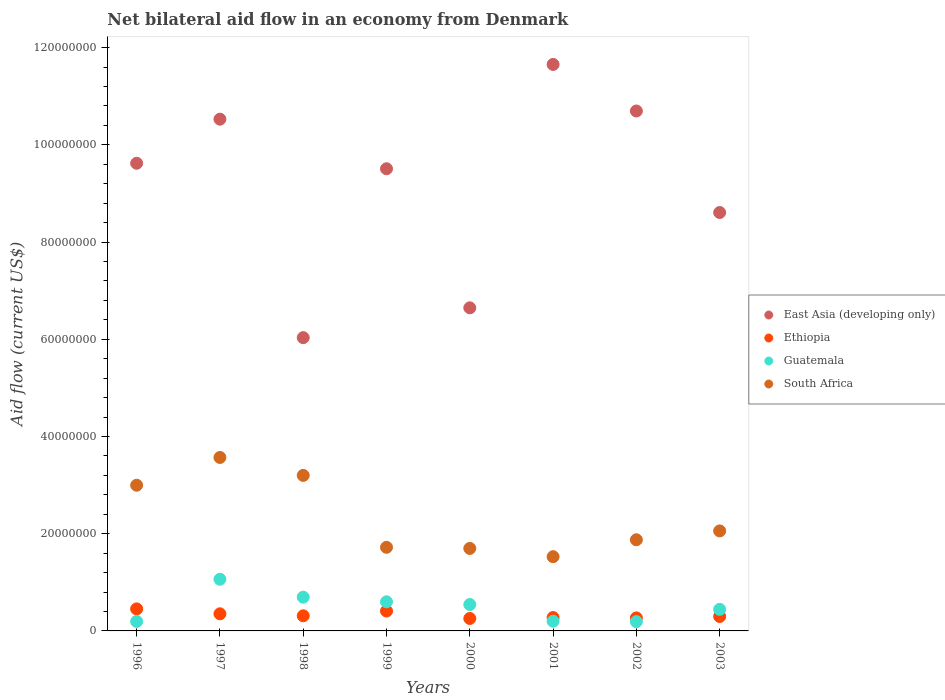Is the number of dotlines equal to the number of legend labels?
Ensure brevity in your answer.  Yes. What is the net bilateral aid flow in Ethiopia in 2000?
Keep it short and to the point. 2.56e+06. Across all years, what is the maximum net bilateral aid flow in Ethiopia?
Provide a short and direct response. 4.53e+06. Across all years, what is the minimum net bilateral aid flow in Ethiopia?
Keep it short and to the point. 2.56e+06. What is the total net bilateral aid flow in South Africa in the graph?
Offer a very short reply. 1.86e+08. What is the difference between the net bilateral aid flow in South Africa in 1999 and that in 2001?
Offer a terse response. 1.93e+06. What is the difference between the net bilateral aid flow in South Africa in 1998 and the net bilateral aid flow in East Asia (developing only) in 1999?
Your response must be concise. -6.31e+07. What is the average net bilateral aid flow in South Africa per year?
Your response must be concise. 2.33e+07. In the year 1998, what is the difference between the net bilateral aid flow in South Africa and net bilateral aid flow in East Asia (developing only)?
Your answer should be compact. -2.83e+07. In how many years, is the net bilateral aid flow in Guatemala greater than 92000000 US$?
Keep it short and to the point. 0. What is the ratio of the net bilateral aid flow in Ethiopia in 1997 to that in 1998?
Your response must be concise. 1.13. Is the net bilateral aid flow in Guatemala in 2000 less than that in 2001?
Provide a short and direct response. No. Is the difference between the net bilateral aid flow in South Africa in 1996 and 2001 greater than the difference between the net bilateral aid flow in East Asia (developing only) in 1996 and 2001?
Your answer should be compact. Yes. What is the difference between the highest and the second highest net bilateral aid flow in South Africa?
Provide a succinct answer. 3.69e+06. What is the difference between the highest and the lowest net bilateral aid flow in South Africa?
Offer a terse response. 2.04e+07. Does the net bilateral aid flow in Ethiopia monotonically increase over the years?
Provide a succinct answer. No. How many dotlines are there?
Your answer should be very brief. 4. How many years are there in the graph?
Your response must be concise. 8. What is the difference between two consecutive major ticks on the Y-axis?
Make the answer very short. 2.00e+07. Does the graph contain grids?
Offer a very short reply. No. How are the legend labels stacked?
Provide a succinct answer. Vertical. What is the title of the graph?
Keep it short and to the point. Net bilateral aid flow in an economy from Denmark. Does "Qatar" appear as one of the legend labels in the graph?
Your answer should be very brief. No. What is the label or title of the X-axis?
Provide a succinct answer. Years. What is the Aid flow (current US$) in East Asia (developing only) in 1996?
Offer a terse response. 9.62e+07. What is the Aid flow (current US$) in Ethiopia in 1996?
Provide a succinct answer. 4.53e+06. What is the Aid flow (current US$) of Guatemala in 1996?
Offer a terse response. 1.95e+06. What is the Aid flow (current US$) of South Africa in 1996?
Offer a very short reply. 3.00e+07. What is the Aid flow (current US$) of East Asia (developing only) in 1997?
Ensure brevity in your answer.  1.05e+08. What is the Aid flow (current US$) in Ethiopia in 1997?
Offer a terse response. 3.52e+06. What is the Aid flow (current US$) in Guatemala in 1997?
Offer a terse response. 1.06e+07. What is the Aid flow (current US$) in South Africa in 1997?
Provide a short and direct response. 3.57e+07. What is the Aid flow (current US$) in East Asia (developing only) in 1998?
Offer a terse response. 6.03e+07. What is the Aid flow (current US$) in Ethiopia in 1998?
Your answer should be very brief. 3.11e+06. What is the Aid flow (current US$) in Guatemala in 1998?
Provide a succinct answer. 6.94e+06. What is the Aid flow (current US$) of South Africa in 1998?
Make the answer very short. 3.20e+07. What is the Aid flow (current US$) in East Asia (developing only) in 1999?
Offer a terse response. 9.51e+07. What is the Aid flow (current US$) of Ethiopia in 1999?
Make the answer very short. 4.09e+06. What is the Aid flow (current US$) in Guatemala in 1999?
Keep it short and to the point. 5.99e+06. What is the Aid flow (current US$) in South Africa in 1999?
Offer a very short reply. 1.72e+07. What is the Aid flow (current US$) in East Asia (developing only) in 2000?
Make the answer very short. 6.65e+07. What is the Aid flow (current US$) of Ethiopia in 2000?
Give a very brief answer. 2.56e+06. What is the Aid flow (current US$) in Guatemala in 2000?
Your answer should be compact. 5.43e+06. What is the Aid flow (current US$) of South Africa in 2000?
Your answer should be compact. 1.70e+07. What is the Aid flow (current US$) in East Asia (developing only) in 2001?
Your answer should be compact. 1.17e+08. What is the Aid flow (current US$) in Ethiopia in 2001?
Offer a very short reply. 2.75e+06. What is the Aid flow (current US$) in Guatemala in 2001?
Keep it short and to the point. 2.00e+06. What is the Aid flow (current US$) in South Africa in 2001?
Keep it short and to the point. 1.53e+07. What is the Aid flow (current US$) of East Asia (developing only) in 2002?
Provide a succinct answer. 1.07e+08. What is the Aid flow (current US$) in Ethiopia in 2002?
Ensure brevity in your answer.  2.68e+06. What is the Aid flow (current US$) in Guatemala in 2002?
Give a very brief answer. 1.91e+06. What is the Aid flow (current US$) of South Africa in 2002?
Provide a succinct answer. 1.88e+07. What is the Aid flow (current US$) in East Asia (developing only) in 2003?
Give a very brief answer. 8.61e+07. What is the Aid flow (current US$) of Ethiopia in 2003?
Provide a succinct answer. 2.97e+06. What is the Aid flow (current US$) of Guatemala in 2003?
Keep it short and to the point. 4.44e+06. What is the Aid flow (current US$) of South Africa in 2003?
Offer a very short reply. 2.06e+07. Across all years, what is the maximum Aid flow (current US$) of East Asia (developing only)?
Keep it short and to the point. 1.17e+08. Across all years, what is the maximum Aid flow (current US$) in Ethiopia?
Your answer should be compact. 4.53e+06. Across all years, what is the maximum Aid flow (current US$) in Guatemala?
Keep it short and to the point. 1.06e+07. Across all years, what is the maximum Aid flow (current US$) of South Africa?
Your response must be concise. 3.57e+07. Across all years, what is the minimum Aid flow (current US$) of East Asia (developing only)?
Your response must be concise. 6.03e+07. Across all years, what is the minimum Aid flow (current US$) of Ethiopia?
Offer a terse response. 2.56e+06. Across all years, what is the minimum Aid flow (current US$) of Guatemala?
Provide a short and direct response. 1.91e+06. Across all years, what is the minimum Aid flow (current US$) in South Africa?
Make the answer very short. 1.53e+07. What is the total Aid flow (current US$) of East Asia (developing only) in the graph?
Provide a succinct answer. 7.33e+08. What is the total Aid flow (current US$) of Ethiopia in the graph?
Offer a very short reply. 2.62e+07. What is the total Aid flow (current US$) in Guatemala in the graph?
Provide a succinct answer. 3.93e+07. What is the total Aid flow (current US$) in South Africa in the graph?
Give a very brief answer. 1.86e+08. What is the difference between the Aid flow (current US$) of East Asia (developing only) in 1996 and that in 1997?
Your response must be concise. -9.07e+06. What is the difference between the Aid flow (current US$) in Ethiopia in 1996 and that in 1997?
Ensure brevity in your answer.  1.01e+06. What is the difference between the Aid flow (current US$) of Guatemala in 1996 and that in 1997?
Your answer should be compact. -8.68e+06. What is the difference between the Aid flow (current US$) of South Africa in 1996 and that in 1997?
Provide a succinct answer. -5.71e+06. What is the difference between the Aid flow (current US$) in East Asia (developing only) in 1996 and that in 1998?
Offer a terse response. 3.59e+07. What is the difference between the Aid flow (current US$) in Ethiopia in 1996 and that in 1998?
Your answer should be compact. 1.42e+06. What is the difference between the Aid flow (current US$) of Guatemala in 1996 and that in 1998?
Offer a terse response. -4.99e+06. What is the difference between the Aid flow (current US$) of South Africa in 1996 and that in 1998?
Offer a very short reply. -2.02e+06. What is the difference between the Aid flow (current US$) in East Asia (developing only) in 1996 and that in 1999?
Offer a very short reply. 1.13e+06. What is the difference between the Aid flow (current US$) in Ethiopia in 1996 and that in 1999?
Provide a short and direct response. 4.40e+05. What is the difference between the Aid flow (current US$) of Guatemala in 1996 and that in 1999?
Offer a very short reply. -4.04e+06. What is the difference between the Aid flow (current US$) of South Africa in 1996 and that in 1999?
Keep it short and to the point. 1.28e+07. What is the difference between the Aid flow (current US$) in East Asia (developing only) in 1996 and that in 2000?
Offer a terse response. 2.97e+07. What is the difference between the Aid flow (current US$) in Ethiopia in 1996 and that in 2000?
Provide a short and direct response. 1.97e+06. What is the difference between the Aid flow (current US$) in Guatemala in 1996 and that in 2000?
Keep it short and to the point. -3.48e+06. What is the difference between the Aid flow (current US$) of South Africa in 1996 and that in 2000?
Make the answer very short. 1.30e+07. What is the difference between the Aid flow (current US$) of East Asia (developing only) in 1996 and that in 2001?
Your answer should be very brief. -2.03e+07. What is the difference between the Aid flow (current US$) in Ethiopia in 1996 and that in 2001?
Keep it short and to the point. 1.78e+06. What is the difference between the Aid flow (current US$) in Guatemala in 1996 and that in 2001?
Offer a very short reply. -5.00e+04. What is the difference between the Aid flow (current US$) in South Africa in 1996 and that in 2001?
Ensure brevity in your answer.  1.47e+07. What is the difference between the Aid flow (current US$) of East Asia (developing only) in 1996 and that in 2002?
Your answer should be very brief. -1.08e+07. What is the difference between the Aid flow (current US$) of Ethiopia in 1996 and that in 2002?
Your answer should be very brief. 1.85e+06. What is the difference between the Aid flow (current US$) in Guatemala in 1996 and that in 2002?
Your answer should be very brief. 4.00e+04. What is the difference between the Aid flow (current US$) in South Africa in 1996 and that in 2002?
Your answer should be compact. 1.12e+07. What is the difference between the Aid flow (current US$) of East Asia (developing only) in 1996 and that in 2003?
Keep it short and to the point. 1.01e+07. What is the difference between the Aid flow (current US$) in Ethiopia in 1996 and that in 2003?
Your answer should be very brief. 1.56e+06. What is the difference between the Aid flow (current US$) in Guatemala in 1996 and that in 2003?
Your answer should be compact. -2.49e+06. What is the difference between the Aid flow (current US$) in South Africa in 1996 and that in 2003?
Your answer should be compact. 9.40e+06. What is the difference between the Aid flow (current US$) in East Asia (developing only) in 1997 and that in 1998?
Make the answer very short. 4.49e+07. What is the difference between the Aid flow (current US$) in Guatemala in 1997 and that in 1998?
Make the answer very short. 3.69e+06. What is the difference between the Aid flow (current US$) in South Africa in 1997 and that in 1998?
Provide a short and direct response. 3.69e+06. What is the difference between the Aid flow (current US$) in East Asia (developing only) in 1997 and that in 1999?
Offer a terse response. 1.02e+07. What is the difference between the Aid flow (current US$) of Ethiopia in 1997 and that in 1999?
Give a very brief answer. -5.70e+05. What is the difference between the Aid flow (current US$) of Guatemala in 1997 and that in 1999?
Give a very brief answer. 4.64e+06. What is the difference between the Aid flow (current US$) of South Africa in 1997 and that in 1999?
Make the answer very short. 1.85e+07. What is the difference between the Aid flow (current US$) in East Asia (developing only) in 1997 and that in 2000?
Offer a very short reply. 3.88e+07. What is the difference between the Aid flow (current US$) of Ethiopia in 1997 and that in 2000?
Ensure brevity in your answer.  9.60e+05. What is the difference between the Aid flow (current US$) in Guatemala in 1997 and that in 2000?
Your response must be concise. 5.20e+06. What is the difference between the Aid flow (current US$) in South Africa in 1997 and that in 2000?
Offer a terse response. 1.87e+07. What is the difference between the Aid flow (current US$) of East Asia (developing only) in 1997 and that in 2001?
Provide a succinct answer. -1.13e+07. What is the difference between the Aid flow (current US$) in Ethiopia in 1997 and that in 2001?
Your response must be concise. 7.70e+05. What is the difference between the Aid flow (current US$) in Guatemala in 1997 and that in 2001?
Your response must be concise. 8.63e+06. What is the difference between the Aid flow (current US$) in South Africa in 1997 and that in 2001?
Make the answer very short. 2.04e+07. What is the difference between the Aid flow (current US$) in East Asia (developing only) in 1997 and that in 2002?
Offer a very short reply. -1.68e+06. What is the difference between the Aid flow (current US$) of Ethiopia in 1997 and that in 2002?
Ensure brevity in your answer.  8.40e+05. What is the difference between the Aid flow (current US$) in Guatemala in 1997 and that in 2002?
Your answer should be very brief. 8.72e+06. What is the difference between the Aid flow (current US$) in South Africa in 1997 and that in 2002?
Provide a short and direct response. 1.69e+07. What is the difference between the Aid flow (current US$) of East Asia (developing only) in 1997 and that in 2003?
Offer a very short reply. 1.92e+07. What is the difference between the Aid flow (current US$) in Ethiopia in 1997 and that in 2003?
Provide a succinct answer. 5.50e+05. What is the difference between the Aid flow (current US$) of Guatemala in 1997 and that in 2003?
Your response must be concise. 6.19e+06. What is the difference between the Aid flow (current US$) in South Africa in 1997 and that in 2003?
Ensure brevity in your answer.  1.51e+07. What is the difference between the Aid flow (current US$) in East Asia (developing only) in 1998 and that in 1999?
Keep it short and to the point. -3.47e+07. What is the difference between the Aid flow (current US$) in Ethiopia in 1998 and that in 1999?
Ensure brevity in your answer.  -9.80e+05. What is the difference between the Aid flow (current US$) of Guatemala in 1998 and that in 1999?
Provide a short and direct response. 9.50e+05. What is the difference between the Aid flow (current US$) of South Africa in 1998 and that in 1999?
Make the answer very short. 1.48e+07. What is the difference between the Aid flow (current US$) of East Asia (developing only) in 1998 and that in 2000?
Provide a succinct answer. -6.13e+06. What is the difference between the Aid flow (current US$) of Guatemala in 1998 and that in 2000?
Your answer should be very brief. 1.51e+06. What is the difference between the Aid flow (current US$) in South Africa in 1998 and that in 2000?
Provide a succinct answer. 1.50e+07. What is the difference between the Aid flow (current US$) in East Asia (developing only) in 1998 and that in 2001?
Ensure brevity in your answer.  -5.62e+07. What is the difference between the Aid flow (current US$) in Guatemala in 1998 and that in 2001?
Ensure brevity in your answer.  4.94e+06. What is the difference between the Aid flow (current US$) in South Africa in 1998 and that in 2001?
Offer a very short reply. 1.67e+07. What is the difference between the Aid flow (current US$) in East Asia (developing only) in 1998 and that in 2002?
Your answer should be compact. -4.66e+07. What is the difference between the Aid flow (current US$) in Guatemala in 1998 and that in 2002?
Your answer should be compact. 5.03e+06. What is the difference between the Aid flow (current US$) in South Africa in 1998 and that in 2002?
Make the answer very short. 1.32e+07. What is the difference between the Aid flow (current US$) in East Asia (developing only) in 1998 and that in 2003?
Ensure brevity in your answer.  -2.57e+07. What is the difference between the Aid flow (current US$) of Ethiopia in 1998 and that in 2003?
Provide a short and direct response. 1.40e+05. What is the difference between the Aid flow (current US$) of Guatemala in 1998 and that in 2003?
Make the answer very short. 2.50e+06. What is the difference between the Aid flow (current US$) of South Africa in 1998 and that in 2003?
Offer a terse response. 1.14e+07. What is the difference between the Aid flow (current US$) in East Asia (developing only) in 1999 and that in 2000?
Ensure brevity in your answer.  2.86e+07. What is the difference between the Aid flow (current US$) in Ethiopia in 1999 and that in 2000?
Offer a terse response. 1.53e+06. What is the difference between the Aid flow (current US$) in Guatemala in 1999 and that in 2000?
Provide a succinct answer. 5.60e+05. What is the difference between the Aid flow (current US$) in South Africa in 1999 and that in 2000?
Make the answer very short. 2.30e+05. What is the difference between the Aid flow (current US$) of East Asia (developing only) in 1999 and that in 2001?
Provide a short and direct response. -2.15e+07. What is the difference between the Aid flow (current US$) of Ethiopia in 1999 and that in 2001?
Make the answer very short. 1.34e+06. What is the difference between the Aid flow (current US$) of Guatemala in 1999 and that in 2001?
Keep it short and to the point. 3.99e+06. What is the difference between the Aid flow (current US$) in South Africa in 1999 and that in 2001?
Offer a very short reply. 1.93e+06. What is the difference between the Aid flow (current US$) in East Asia (developing only) in 1999 and that in 2002?
Provide a succinct answer. -1.19e+07. What is the difference between the Aid flow (current US$) in Ethiopia in 1999 and that in 2002?
Give a very brief answer. 1.41e+06. What is the difference between the Aid flow (current US$) in Guatemala in 1999 and that in 2002?
Keep it short and to the point. 4.08e+06. What is the difference between the Aid flow (current US$) in South Africa in 1999 and that in 2002?
Ensure brevity in your answer.  -1.55e+06. What is the difference between the Aid flow (current US$) in East Asia (developing only) in 1999 and that in 2003?
Provide a short and direct response. 9.00e+06. What is the difference between the Aid flow (current US$) in Ethiopia in 1999 and that in 2003?
Offer a terse response. 1.12e+06. What is the difference between the Aid flow (current US$) in Guatemala in 1999 and that in 2003?
Keep it short and to the point. 1.55e+06. What is the difference between the Aid flow (current US$) of South Africa in 1999 and that in 2003?
Give a very brief answer. -3.37e+06. What is the difference between the Aid flow (current US$) of East Asia (developing only) in 2000 and that in 2001?
Offer a terse response. -5.01e+07. What is the difference between the Aid flow (current US$) in Ethiopia in 2000 and that in 2001?
Offer a very short reply. -1.90e+05. What is the difference between the Aid flow (current US$) of Guatemala in 2000 and that in 2001?
Your response must be concise. 3.43e+06. What is the difference between the Aid flow (current US$) in South Africa in 2000 and that in 2001?
Give a very brief answer. 1.70e+06. What is the difference between the Aid flow (current US$) in East Asia (developing only) in 2000 and that in 2002?
Offer a very short reply. -4.05e+07. What is the difference between the Aid flow (current US$) of Ethiopia in 2000 and that in 2002?
Your answer should be compact. -1.20e+05. What is the difference between the Aid flow (current US$) of Guatemala in 2000 and that in 2002?
Your answer should be very brief. 3.52e+06. What is the difference between the Aid flow (current US$) in South Africa in 2000 and that in 2002?
Your answer should be compact. -1.78e+06. What is the difference between the Aid flow (current US$) of East Asia (developing only) in 2000 and that in 2003?
Your response must be concise. -1.96e+07. What is the difference between the Aid flow (current US$) of Ethiopia in 2000 and that in 2003?
Make the answer very short. -4.10e+05. What is the difference between the Aid flow (current US$) of Guatemala in 2000 and that in 2003?
Ensure brevity in your answer.  9.90e+05. What is the difference between the Aid flow (current US$) in South Africa in 2000 and that in 2003?
Offer a terse response. -3.60e+06. What is the difference between the Aid flow (current US$) of East Asia (developing only) in 2001 and that in 2002?
Make the answer very short. 9.58e+06. What is the difference between the Aid flow (current US$) of South Africa in 2001 and that in 2002?
Your response must be concise. -3.48e+06. What is the difference between the Aid flow (current US$) of East Asia (developing only) in 2001 and that in 2003?
Keep it short and to the point. 3.05e+07. What is the difference between the Aid flow (current US$) in Guatemala in 2001 and that in 2003?
Your response must be concise. -2.44e+06. What is the difference between the Aid flow (current US$) in South Africa in 2001 and that in 2003?
Offer a very short reply. -5.30e+06. What is the difference between the Aid flow (current US$) in East Asia (developing only) in 2002 and that in 2003?
Provide a succinct answer. 2.09e+07. What is the difference between the Aid flow (current US$) of Ethiopia in 2002 and that in 2003?
Your response must be concise. -2.90e+05. What is the difference between the Aid flow (current US$) of Guatemala in 2002 and that in 2003?
Your response must be concise. -2.53e+06. What is the difference between the Aid flow (current US$) of South Africa in 2002 and that in 2003?
Make the answer very short. -1.82e+06. What is the difference between the Aid flow (current US$) of East Asia (developing only) in 1996 and the Aid flow (current US$) of Ethiopia in 1997?
Provide a succinct answer. 9.27e+07. What is the difference between the Aid flow (current US$) of East Asia (developing only) in 1996 and the Aid flow (current US$) of Guatemala in 1997?
Your answer should be very brief. 8.56e+07. What is the difference between the Aid flow (current US$) in East Asia (developing only) in 1996 and the Aid flow (current US$) in South Africa in 1997?
Provide a short and direct response. 6.05e+07. What is the difference between the Aid flow (current US$) in Ethiopia in 1996 and the Aid flow (current US$) in Guatemala in 1997?
Provide a succinct answer. -6.10e+06. What is the difference between the Aid flow (current US$) in Ethiopia in 1996 and the Aid flow (current US$) in South Africa in 1997?
Provide a succinct answer. -3.12e+07. What is the difference between the Aid flow (current US$) of Guatemala in 1996 and the Aid flow (current US$) of South Africa in 1997?
Provide a short and direct response. -3.37e+07. What is the difference between the Aid flow (current US$) of East Asia (developing only) in 1996 and the Aid flow (current US$) of Ethiopia in 1998?
Make the answer very short. 9.31e+07. What is the difference between the Aid flow (current US$) of East Asia (developing only) in 1996 and the Aid flow (current US$) of Guatemala in 1998?
Provide a short and direct response. 8.93e+07. What is the difference between the Aid flow (current US$) of East Asia (developing only) in 1996 and the Aid flow (current US$) of South Africa in 1998?
Give a very brief answer. 6.42e+07. What is the difference between the Aid flow (current US$) of Ethiopia in 1996 and the Aid flow (current US$) of Guatemala in 1998?
Keep it short and to the point. -2.41e+06. What is the difference between the Aid flow (current US$) of Ethiopia in 1996 and the Aid flow (current US$) of South Africa in 1998?
Provide a succinct answer. -2.75e+07. What is the difference between the Aid flow (current US$) in Guatemala in 1996 and the Aid flow (current US$) in South Africa in 1998?
Give a very brief answer. -3.00e+07. What is the difference between the Aid flow (current US$) in East Asia (developing only) in 1996 and the Aid flow (current US$) in Ethiopia in 1999?
Your answer should be very brief. 9.21e+07. What is the difference between the Aid flow (current US$) in East Asia (developing only) in 1996 and the Aid flow (current US$) in Guatemala in 1999?
Offer a terse response. 9.02e+07. What is the difference between the Aid flow (current US$) of East Asia (developing only) in 1996 and the Aid flow (current US$) of South Africa in 1999?
Make the answer very short. 7.90e+07. What is the difference between the Aid flow (current US$) in Ethiopia in 1996 and the Aid flow (current US$) in Guatemala in 1999?
Your response must be concise. -1.46e+06. What is the difference between the Aid flow (current US$) in Ethiopia in 1996 and the Aid flow (current US$) in South Africa in 1999?
Provide a succinct answer. -1.27e+07. What is the difference between the Aid flow (current US$) of Guatemala in 1996 and the Aid flow (current US$) of South Africa in 1999?
Your answer should be compact. -1.52e+07. What is the difference between the Aid flow (current US$) of East Asia (developing only) in 1996 and the Aid flow (current US$) of Ethiopia in 2000?
Give a very brief answer. 9.36e+07. What is the difference between the Aid flow (current US$) in East Asia (developing only) in 1996 and the Aid flow (current US$) in Guatemala in 2000?
Ensure brevity in your answer.  9.08e+07. What is the difference between the Aid flow (current US$) of East Asia (developing only) in 1996 and the Aid flow (current US$) of South Africa in 2000?
Provide a succinct answer. 7.92e+07. What is the difference between the Aid flow (current US$) in Ethiopia in 1996 and the Aid flow (current US$) in Guatemala in 2000?
Your answer should be compact. -9.00e+05. What is the difference between the Aid flow (current US$) of Ethiopia in 1996 and the Aid flow (current US$) of South Africa in 2000?
Offer a very short reply. -1.24e+07. What is the difference between the Aid flow (current US$) in Guatemala in 1996 and the Aid flow (current US$) in South Africa in 2000?
Your answer should be compact. -1.50e+07. What is the difference between the Aid flow (current US$) of East Asia (developing only) in 1996 and the Aid flow (current US$) of Ethiopia in 2001?
Give a very brief answer. 9.34e+07. What is the difference between the Aid flow (current US$) in East Asia (developing only) in 1996 and the Aid flow (current US$) in Guatemala in 2001?
Give a very brief answer. 9.42e+07. What is the difference between the Aid flow (current US$) in East Asia (developing only) in 1996 and the Aid flow (current US$) in South Africa in 2001?
Offer a very short reply. 8.09e+07. What is the difference between the Aid flow (current US$) of Ethiopia in 1996 and the Aid flow (current US$) of Guatemala in 2001?
Offer a very short reply. 2.53e+06. What is the difference between the Aid flow (current US$) of Ethiopia in 1996 and the Aid flow (current US$) of South Africa in 2001?
Your answer should be very brief. -1.07e+07. What is the difference between the Aid flow (current US$) of Guatemala in 1996 and the Aid flow (current US$) of South Africa in 2001?
Provide a succinct answer. -1.33e+07. What is the difference between the Aid flow (current US$) in East Asia (developing only) in 1996 and the Aid flow (current US$) in Ethiopia in 2002?
Your answer should be very brief. 9.35e+07. What is the difference between the Aid flow (current US$) in East Asia (developing only) in 1996 and the Aid flow (current US$) in Guatemala in 2002?
Your response must be concise. 9.43e+07. What is the difference between the Aid flow (current US$) of East Asia (developing only) in 1996 and the Aid flow (current US$) of South Africa in 2002?
Provide a short and direct response. 7.74e+07. What is the difference between the Aid flow (current US$) in Ethiopia in 1996 and the Aid flow (current US$) in Guatemala in 2002?
Offer a terse response. 2.62e+06. What is the difference between the Aid flow (current US$) in Ethiopia in 1996 and the Aid flow (current US$) in South Africa in 2002?
Provide a short and direct response. -1.42e+07. What is the difference between the Aid flow (current US$) of Guatemala in 1996 and the Aid flow (current US$) of South Africa in 2002?
Your response must be concise. -1.68e+07. What is the difference between the Aid flow (current US$) of East Asia (developing only) in 1996 and the Aid flow (current US$) of Ethiopia in 2003?
Make the answer very short. 9.32e+07. What is the difference between the Aid flow (current US$) of East Asia (developing only) in 1996 and the Aid flow (current US$) of Guatemala in 2003?
Make the answer very short. 9.18e+07. What is the difference between the Aid flow (current US$) of East Asia (developing only) in 1996 and the Aid flow (current US$) of South Africa in 2003?
Provide a short and direct response. 7.56e+07. What is the difference between the Aid flow (current US$) of Ethiopia in 1996 and the Aid flow (current US$) of Guatemala in 2003?
Offer a very short reply. 9.00e+04. What is the difference between the Aid flow (current US$) of Ethiopia in 1996 and the Aid flow (current US$) of South Africa in 2003?
Ensure brevity in your answer.  -1.60e+07. What is the difference between the Aid flow (current US$) in Guatemala in 1996 and the Aid flow (current US$) in South Africa in 2003?
Your answer should be very brief. -1.86e+07. What is the difference between the Aid flow (current US$) in East Asia (developing only) in 1997 and the Aid flow (current US$) in Ethiopia in 1998?
Provide a succinct answer. 1.02e+08. What is the difference between the Aid flow (current US$) of East Asia (developing only) in 1997 and the Aid flow (current US$) of Guatemala in 1998?
Give a very brief answer. 9.83e+07. What is the difference between the Aid flow (current US$) in East Asia (developing only) in 1997 and the Aid flow (current US$) in South Africa in 1998?
Provide a short and direct response. 7.33e+07. What is the difference between the Aid flow (current US$) in Ethiopia in 1997 and the Aid flow (current US$) in Guatemala in 1998?
Your response must be concise. -3.42e+06. What is the difference between the Aid flow (current US$) in Ethiopia in 1997 and the Aid flow (current US$) in South Africa in 1998?
Provide a succinct answer. -2.85e+07. What is the difference between the Aid flow (current US$) of Guatemala in 1997 and the Aid flow (current US$) of South Africa in 1998?
Your response must be concise. -2.14e+07. What is the difference between the Aid flow (current US$) in East Asia (developing only) in 1997 and the Aid flow (current US$) in Ethiopia in 1999?
Provide a short and direct response. 1.01e+08. What is the difference between the Aid flow (current US$) of East Asia (developing only) in 1997 and the Aid flow (current US$) of Guatemala in 1999?
Provide a succinct answer. 9.93e+07. What is the difference between the Aid flow (current US$) of East Asia (developing only) in 1997 and the Aid flow (current US$) of South Africa in 1999?
Provide a short and direct response. 8.81e+07. What is the difference between the Aid flow (current US$) in Ethiopia in 1997 and the Aid flow (current US$) in Guatemala in 1999?
Your response must be concise. -2.47e+06. What is the difference between the Aid flow (current US$) in Ethiopia in 1997 and the Aid flow (current US$) in South Africa in 1999?
Your response must be concise. -1.37e+07. What is the difference between the Aid flow (current US$) in Guatemala in 1997 and the Aid flow (current US$) in South Africa in 1999?
Ensure brevity in your answer.  -6.57e+06. What is the difference between the Aid flow (current US$) in East Asia (developing only) in 1997 and the Aid flow (current US$) in Ethiopia in 2000?
Your answer should be very brief. 1.03e+08. What is the difference between the Aid flow (current US$) in East Asia (developing only) in 1997 and the Aid flow (current US$) in Guatemala in 2000?
Offer a very short reply. 9.98e+07. What is the difference between the Aid flow (current US$) of East Asia (developing only) in 1997 and the Aid flow (current US$) of South Africa in 2000?
Keep it short and to the point. 8.83e+07. What is the difference between the Aid flow (current US$) of Ethiopia in 1997 and the Aid flow (current US$) of Guatemala in 2000?
Ensure brevity in your answer.  -1.91e+06. What is the difference between the Aid flow (current US$) of Ethiopia in 1997 and the Aid flow (current US$) of South Africa in 2000?
Ensure brevity in your answer.  -1.34e+07. What is the difference between the Aid flow (current US$) of Guatemala in 1997 and the Aid flow (current US$) of South Africa in 2000?
Offer a very short reply. -6.34e+06. What is the difference between the Aid flow (current US$) in East Asia (developing only) in 1997 and the Aid flow (current US$) in Ethiopia in 2001?
Your response must be concise. 1.03e+08. What is the difference between the Aid flow (current US$) in East Asia (developing only) in 1997 and the Aid flow (current US$) in Guatemala in 2001?
Make the answer very short. 1.03e+08. What is the difference between the Aid flow (current US$) of East Asia (developing only) in 1997 and the Aid flow (current US$) of South Africa in 2001?
Provide a short and direct response. 9.00e+07. What is the difference between the Aid flow (current US$) in Ethiopia in 1997 and the Aid flow (current US$) in Guatemala in 2001?
Your answer should be very brief. 1.52e+06. What is the difference between the Aid flow (current US$) of Ethiopia in 1997 and the Aid flow (current US$) of South Africa in 2001?
Give a very brief answer. -1.18e+07. What is the difference between the Aid flow (current US$) of Guatemala in 1997 and the Aid flow (current US$) of South Africa in 2001?
Provide a succinct answer. -4.64e+06. What is the difference between the Aid flow (current US$) in East Asia (developing only) in 1997 and the Aid flow (current US$) in Ethiopia in 2002?
Give a very brief answer. 1.03e+08. What is the difference between the Aid flow (current US$) of East Asia (developing only) in 1997 and the Aid flow (current US$) of Guatemala in 2002?
Your answer should be very brief. 1.03e+08. What is the difference between the Aid flow (current US$) in East Asia (developing only) in 1997 and the Aid flow (current US$) in South Africa in 2002?
Provide a succinct answer. 8.65e+07. What is the difference between the Aid flow (current US$) of Ethiopia in 1997 and the Aid flow (current US$) of Guatemala in 2002?
Provide a short and direct response. 1.61e+06. What is the difference between the Aid flow (current US$) in Ethiopia in 1997 and the Aid flow (current US$) in South Africa in 2002?
Your answer should be compact. -1.52e+07. What is the difference between the Aid flow (current US$) in Guatemala in 1997 and the Aid flow (current US$) in South Africa in 2002?
Offer a terse response. -8.12e+06. What is the difference between the Aid flow (current US$) in East Asia (developing only) in 1997 and the Aid flow (current US$) in Ethiopia in 2003?
Keep it short and to the point. 1.02e+08. What is the difference between the Aid flow (current US$) of East Asia (developing only) in 1997 and the Aid flow (current US$) of Guatemala in 2003?
Ensure brevity in your answer.  1.01e+08. What is the difference between the Aid flow (current US$) in East Asia (developing only) in 1997 and the Aid flow (current US$) in South Africa in 2003?
Offer a terse response. 8.47e+07. What is the difference between the Aid flow (current US$) of Ethiopia in 1997 and the Aid flow (current US$) of Guatemala in 2003?
Give a very brief answer. -9.20e+05. What is the difference between the Aid flow (current US$) of Ethiopia in 1997 and the Aid flow (current US$) of South Africa in 2003?
Provide a succinct answer. -1.70e+07. What is the difference between the Aid flow (current US$) in Guatemala in 1997 and the Aid flow (current US$) in South Africa in 2003?
Your answer should be very brief. -9.94e+06. What is the difference between the Aid flow (current US$) of East Asia (developing only) in 1998 and the Aid flow (current US$) of Ethiopia in 1999?
Provide a short and direct response. 5.62e+07. What is the difference between the Aid flow (current US$) in East Asia (developing only) in 1998 and the Aid flow (current US$) in Guatemala in 1999?
Provide a succinct answer. 5.43e+07. What is the difference between the Aid flow (current US$) of East Asia (developing only) in 1998 and the Aid flow (current US$) of South Africa in 1999?
Ensure brevity in your answer.  4.31e+07. What is the difference between the Aid flow (current US$) in Ethiopia in 1998 and the Aid flow (current US$) in Guatemala in 1999?
Make the answer very short. -2.88e+06. What is the difference between the Aid flow (current US$) of Ethiopia in 1998 and the Aid flow (current US$) of South Africa in 1999?
Make the answer very short. -1.41e+07. What is the difference between the Aid flow (current US$) of Guatemala in 1998 and the Aid flow (current US$) of South Africa in 1999?
Your response must be concise. -1.03e+07. What is the difference between the Aid flow (current US$) in East Asia (developing only) in 1998 and the Aid flow (current US$) in Ethiopia in 2000?
Provide a short and direct response. 5.78e+07. What is the difference between the Aid flow (current US$) of East Asia (developing only) in 1998 and the Aid flow (current US$) of Guatemala in 2000?
Your answer should be very brief. 5.49e+07. What is the difference between the Aid flow (current US$) in East Asia (developing only) in 1998 and the Aid flow (current US$) in South Africa in 2000?
Keep it short and to the point. 4.34e+07. What is the difference between the Aid flow (current US$) in Ethiopia in 1998 and the Aid flow (current US$) in Guatemala in 2000?
Give a very brief answer. -2.32e+06. What is the difference between the Aid flow (current US$) of Ethiopia in 1998 and the Aid flow (current US$) of South Africa in 2000?
Ensure brevity in your answer.  -1.39e+07. What is the difference between the Aid flow (current US$) of Guatemala in 1998 and the Aid flow (current US$) of South Africa in 2000?
Ensure brevity in your answer.  -1.00e+07. What is the difference between the Aid flow (current US$) of East Asia (developing only) in 1998 and the Aid flow (current US$) of Ethiopia in 2001?
Keep it short and to the point. 5.76e+07. What is the difference between the Aid flow (current US$) in East Asia (developing only) in 1998 and the Aid flow (current US$) in Guatemala in 2001?
Provide a succinct answer. 5.83e+07. What is the difference between the Aid flow (current US$) of East Asia (developing only) in 1998 and the Aid flow (current US$) of South Africa in 2001?
Provide a succinct answer. 4.51e+07. What is the difference between the Aid flow (current US$) of Ethiopia in 1998 and the Aid flow (current US$) of Guatemala in 2001?
Give a very brief answer. 1.11e+06. What is the difference between the Aid flow (current US$) in Ethiopia in 1998 and the Aid flow (current US$) in South Africa in 2001?
Give a very brief answer. -1.22e+07. What is the difference between the Aid flow (current US$) in Guatemala in 1998 and the Aid flow (current US$) in South Africa in 2001?
Keep it short and to the point. -8.33e+06. What is the difference between the Aid flow (current US$) in East Asia (developing only) in 1998 and the Aid flow (current US$) in Ethiopia in 2002?
Offer a very short reply. 5.76e+07. What is the difference between the Aid flow (current US$) of East Asia (developing only) in 1998 and the Aid flow (current US$) of Guatemala in 2002?
Offer a terse response. 5.84e+07. What is the difference between the Aid flow (current US$) in East Asia (developing only) in 1998 and the Aid flow (current US$) in South Africa in 2002?
Provide a succinct answer. 4.16e+07. What is the difference between the Aid flow (current US$) in Ethiopia in 1998 and the Aid flow (current US$) in Guatemala in 2002?
Provide a succinct answer. 1.20e+06. What is the difference between the Aid flow (current US$) of Ethiopia in 1998 and the Aid flow (current US$) of South Africa in 2002?
Provide a succinct answer. -1.56e+07. What is the difference between the Aid flow (current US$) in Guatemala in 1998 and the Aid flow (current US$) in South Africa in 2002?
Your answer should be very brief. -1.18e+07. What is the difference between the Aid flow (current US$) in East Asia (developing only) in 1998 and the Aid flow (current US$) in Ethiopia in 2003?
Offer a terse response. 5.74e+07. What is the difference between the Aid flow (current US$) in East Asia (developing only) in 1998 and the Aid flow (current US$) in Guatemala in 2003?
Ensure brevity in your answer.  5.59e+07. What is the difference between the Aid flow (current US$) in East Asia (developing only) in 1998 and the Aid flow (current US$) in South Africa in 2003?
Provide a short and direct response. 3.98e+07. What is the difference between the Aid flow (current US$) of Ethiopia in 1998 and the Aid flow (current US$) of Guatemala in 2003?
Ensure brevity in your answer.  -1.33e+06. What is the difference between the Aid flow (current US$) of Ethiopia in 1998 and the Aid flow (current US$) of South Africa in 2003?
Your answer should be compact. -1.75e+07. What is the difference between the Aid flow (current US$) in Guatemala in 1998 and the Aid flow (current US$) in South Africa in 2003?
Offer a terse response. -1.36e+07. What is the difference between the Aid flow (current US$) of East Asia (developing only) in 1999 and the Aid flow (current US$) of Ethiopia in 2000?
Ensure brevity in your answer.  9.25e+07. What is the difference between the Aid flow (current US$) in East Asia (developing only) in 1999 and the Aid flow (current US$) in Guatemala in 2000?
Your response must be concise. 8.96e+07. What is the difference between the Aid flow (current US$) in East Asia (developing only) in 1999 and the Aid flow (current US$) in South Africa in 2000?
Your answer should be very brief. 7.81e+07. What is the difference between the Aid flow (current US$) in Ethiopia in 1999 and the Aid flow (current US$) in Guatemala in 2000?
Ensure brevity in your answer.  -1.34e+06. What is the difference between the Aid flow (current US$) of Ethiopia in 1999 and the Aid flow (current US$) of South Africa in 2000?
Keep it short and to the point. -1.29e+07. What is the difference between the Aid flow (current US$) of Guatemala in 1999 and the Aid flow (current US$) of South Africa in 2000?
Give a very brief answer. -1.10e+07. What is the difference between the Aid flow (current US$) in East Asia (developing only) in 1999 and the Aid flow (current US$) in Ethiopia in 2001?
Provide a short and direct response. 9.23e+07. What is the difference between the Aid flow (current US$) in East Asia (developing only) in 1999 and the Aid flow (current US$) in Guatemala in 2001?
Ensure brevity in your answer.  9.31e+07. What is the difference between the Aid flow (current US$) of East Asia (developing only) in 1999 and the Aid flow (current US$) of South Africa in 2001?
Make the answer very short. 7.98e+07. What is the difference between the Aid flow (current US$) in Ethiopia in 1999 and the Aid flow (current US$) in Guatemala in 2001?
Offer a terse response. 2.09e+06. What is the difference between the Aid flow (current US$) of Ethiopia in 1999 and the Aid flow (current US$) of South Africa in 2001?
Your response must be concise. -1.12e+07. What is the difference between the Aid flow (current US$) in Guatemala in 1999 and the Aid flow (current US$) in South Africa in 2001?
Your response must be concise. -9.28e+06. What is the difference between the Aid flow (current US$) in East Asia (developing only) in 1999 and the Aid flow (current US$) in Ethiopia in 2002?
Make the answer very short. 9.24e+07. What is the difference between the Aid flow (current US$) of East Asia (developing only) in 1999 and the Aid flow (current US$) of Guatemala in 2002?
Give a very brief answer. 9.32e+07. What is the difference between the Aid flow (current US$) of East Asia (developing only) in 1999 and the Aid flow (current US$) of South Africa in 2002?
Your response must be concise. 7.63e+07. What is the difference between the Aid flow (current US$) of Ethiopia in 1999 and the Aid flow (current US$) of Guatemala in 2002?
Your response must be concise. 2.18e+06. What is the difference between the Aid flow (current US$) in Ethiopia in 1999 and the Aid flow (current US$) in South Africa in 2002?
Provide a succinct answer. -1.47e+07. What is the difference between the Aid flow (current US$) of Guatemala in 1999 and the Aid flow (current US$) of South Africa in 2002?
Your answer should be very brief. -1.28e+07. What is the difference between the Aid flow (current US$) of East Asia (developing only) in 1999 and the Aid flow (current US$) of Ethiopia in 2003?
Ensure brevity in your answer.  9.21e+07. What is the difference between the Aid flow (current US$) of East Asia (developing only) in 1999 and the Aid flow (current US$) of Guatemala in 2003?
Give a very brief answer. 9.06e+07. What is the difference between the Aid flow (current US$) of East Asia (developing only) in 1999 and the Aid flow (current US$) of South Africa in 2003?
Give a very brief answer. 7.45e+07. What is the difference between the Aid flow (current US$) in Ethiopia in 1999 and the Aid flow (current US$) in Guatemala in 2003?
Your response must be concise. -3.50e+05. What is the difference between the Aid flow (current US$) in Ethiopia in 1999 and the Aid flow (current US$) in South Africa in 2003?
Keep it short and to the point. -1.65e+07. What is the difference between the Aid flow (current US$) in Guatemala in 1999 and the Aid flow (current US$) in South Africa in 2003?
Make the answer very short. -1.46e+07. What is the difference between the Aid flow (current US$) of East Asia (developing only) in 2000 and the Aid flow (current US$) of Ethiopia in 2001?
Your response must be concise. 6.37e+07. What is the difference between the Aid flow (current US$) in East Asia (developing only) in 2000 and the Aid flow (current US$) in Guatemala in 2001?
Offer a terse response. 6.45e+07. What is the difference between the Aid flow (current US$) of East Asia (developing only) in 2000 and the Aid flow (current US$) of South Africa in 2001?
Keep it short and to the point. 5.12e+07. What is the difference between the Aid flow (current US$) in Ethiopia in 2000 and the Aid flow (current US$) in Guatemala in 2001?
Make the answer very short. 5.60e+05. What is the difference between the Aid flow (current US$) of Ethiopia in 2000 and the Aid flow (current US$) of South Africa in 2001?
Your response must be concise. -1.27e+07. What is the difference between the Aid flow (current US$) in Guatemala in 2000 and the Aid flow (current US$) in South Africa in 2001?
Provide a succinct answer. -9.84e+06. What is the difference between the Aid flow (current US$) in East Asia (developing only) in 2000 and the Aid flow (current US$) in Ethiopia in 2002?
Offer a terse response. 6.38e+07. What is the difference between the Aid flow (current US$) in East Asia (developing only) in 2000 and the Aid flow (current US$) in Guatemala in 2002?
Your response must be concise. 6.46e+07. What is the difference between the Aid flow (current US$) in East Asia (developing only) in 2000 and the Aid flow (current US$) in South Africa in 2002?
Make the answer very short. 4.77e+07. What is the difference between the Aid flow (current US$) in Ethiopia in 2000 and the Aid flow (current US$) in Guatemala in 2002?
Your response must be concise. 6.50e+05. What is the difference between the Aid flow (current US$) of Ethiopia in 2000 and the Aid flow (current US$) of South Africa in 2002?
Ensure brevity in your answer.  -1.62e+07. What is the difference between the Aid flow (current US$) in Guatemala in 2000 and the Aid flow (current US$) in South Africa in 2002?
Your answer should be compact. -1.33e+07. What is the difference between the Aid flow (current US$) of East Asia (developing only) in 2000 and the Aid flow (current US$) of Ethiopia in 2003?
Your response must be concise. 6.35e+07. What is the difference between the Aid flow (current US$) in East Asia (developing only) in 2000 and the Aid flow (current US$) in Guatemala in 2003?
Your answer should be very brief. 6.20e+07. What is the difference between the Aid flow (current US$) in East Asia (developing only) in 2000 and the Aid flow (current US$) in South Africa in 2003?
Provide a short and direct response. 4.59e+07. What is the difference between the Aid flow (current US$) of Ethiopia in 2000 and the Aid flow (current US$) of Guatemala in 2003?
Your answer should be very brief. -1.88e+06. What is the difference between the Aid flow (current US$) of Ethiopia in 2000 and the Aid flow (current US$) of South Africa in 2003?
Your response must be concise. -1.80e+07. What is the difference between the Aid flow (current US$) of Guatemala in 2000 and the Aid flow (current US$) of South Africa in 2003?
Give a very brief answer. -1.51e+07. What is the difference between the Aid flow (current US$) in East Asia (developing only) in 2001 and the Aid flow (current US$) in Ethiopia in 2002?
Your response must be concise. 1.14e+08. What is the difference between the Aid flow (current US$) in East Asia (developing only) in 2001 and the Aid flow (current US$) in Guatemala in 2002?
Keep it short and to the point. 1.15e+08. What is the difference between the Aid flow (current US$) in East Asia (developing only) in 2001 and the Aid flow (current US$) in South Africa in 2002?
Provide a short and direct response. 9.78e+07. What is the difference between the Aid flow (current US$) of Ethiopia in 2001 and the Aid flow (current US$) of Guatemala in 2002?
Offer a very short reply. 8.40e+05. What is the difference between the Aid flow (current US$) of Ethiopia in 2001 and the Aid flow (current US$) of South Africa in 2002?
Provide a succinct answer. -1.60e+07. What is the difference between the Aid flow (current US$) in Guatemala in 2001 and the Aid flow (current US$) in South Africa in 2002?
Provide a short and direct response. -1.68e+07. What is the difference between the Aid flow (current US$) in East Asia (developing only) in 2001 and the Aid flow (current US$) in Ethiopia in 2003?
Your response must be concise. 1.14e+08. What is the difference between the Aid flow (current US$) in East Asia (developing only) in 2001 and the Aid flow (current US$) in Guatemala in 2003?
Provide a short and direct response. 1.12e+08. What is the difference between the Aid flow (current US$) of East Asia (developing only) in 2001 and the Aid flow (current US$) of South Africa in 2003?
Keep it short and to the point. 9.60e+07. What is the difference between the Aid flow (current US$) in Ethiopia in 2001 and the Aid flow (current US$) in Guatemala in 2003?
Offer a terse response. -1.69e+06. What is the difference between the Aid flow (current US$) of Ethiopia in 2001 and the Aid flow (current US$) of South Africa in 2003?
Provide a short and direct response. -1.78e+07. What is the difference between the Aid flow (current US$) of Guatemala in 2001 and the Aid flow (current US$) of South Africa in 2003?
Offer a terse response. -1.86e+07. What is the difference between the Aid flow (current US$) in East Asia (developing only) in 2002 and the Aid flow (current US$) in Ethiopia in 2003?
Give a very brief answer. 1.04e+08. What is the difference between the Aid flow (current US$) in East Asia (developing only) in 2002 and the Aid flow (current US$) in Guatemala in 2003?
Ensure brevity in your answer.  1.03e+08. What is the difference between the Aid flow (current US$) of East Asia (developing only) in 2002 and the Aid flow (current US$) of South Africa in 2003?
Your response must be concise. 8.64e+07. What is the difference between the Aid flow (current US$) in Ethiopia in 2002 and the Aid flow (current US$) in Guatemala in 2003?
Offer a very short reply. -1.76e+06. What is the difference between the Aid flow (current US$) in Ethiopia in 2002 and the Aid flow (current US$) in South Africa in 2003?
Offer a very short reply. -1.79e+07. What is the difference between the Aid flow (current US$) of Guatemala in 2002 and the Aid flow (current US$) of South Africa in 2003?
Offer a terse response. -1.87e+07. What is the average Aid flow (current US$) of East Asia (developing only) per year?
Provide a succinct answer. 9.16e+07. What is the average Aid flow (current US$) of Ethiopia per year?
Make the answer very short. 3.28e+06. What is the average Aid flow (current US$) in Guatemala per year?
Give a very brief answer. 4.91e+06. What is the average Aid flow (current US$) in South Africa per year?
Provide a succinct answer. 2.33e+07. In the year 1996, what is the difference between the Aid flow (current US$) of East Asia (developing only) and Aid flow (current US$) of Ethiopia?
Offer a very short reply. 9.17e+07. In the year 1996, what is the difference between the Aid flow (current US$) of East Asia (developing only) and Aid flow (current US$) of Guatemala?
Provide a succinct answer. 9.42e+07. In the year 1996, what is the difference between the Aid flow (current US$) of East Asia (developing only) and Aid flow (current US$) of South Africa?
Give a very brief answer. 6.62e+07. In the year 1996, what is the difference between the Aid flow (current US$) in Ethiopia and Aid flow (current US$) in Guatemala?
Your answer should be very brief. 2.58e+06. In the year 1996, what is the difference between the Aid flow (current US$) in Ethiopia and Aid flow (current US$) in South Africa?
Your answer should be compact. -2.54e+07. In the year 1996, what is the difference between the Aid flow (current US$) in Guatemala and Aid flow (current US$) in South Africa?
Ensure brevity in your answer.  -2.80e+07. In the year 1997, what is the difference between the Aid flow (current US$) in East Asia (developing only) and Aid flow (current US$) in Ethiopia?
Your response must be concise. 1.02e+08. In the year 1997, what is the difference between the Aid flow (current US$) of East Asia (developing only) and Aid flow (current US$) of Guatemala?
Offer a terse response. 9.46e+07. In the year 1997, what is the difference between the Aid flow (current US$) of East Asia (developing only) and Aid flow (current US$) of South Africa?
Provide a succinct answer. 6.96e+07. In the year 1997, what is the difference between the Aid flow (current US$) of Ethiopia and Aid flow (current US$) of Guatemala?
Make the answer very short. -7.11e+06. In the year 1997, what is the difference between the Aid flow (current US$) of Ethiopia and Aid flow (current US$) of South Africa?
Give a very brief answer. -3.22e+07. In the year 1997, what is the difference between the Aid flow (current US$) of Guatemala and Aid flow (current US$) of South Africa?
Offer a very short reply. -2.50e+07. In the year 1998, what is the difference between the Aid flow (current US$) of East Asia (developing only) and Aid flow (current US$) of Ethiopia?
Provide a succinct answer. 5.72e+07. In the year 1998, what is the difference between the Aid flow (current US$) in East Asia (developing only) and Aid flow (current US$) in Guatemala?
Your response must be concise. 5.34e+07. In the year 1998, what is the difference between the Aid flow (current US$) of East Asia (developing only) and Aid flow (current US$) of South Africa?
Your answer should be very brief. 2.83e+07. In the year 1998, what is the difference between the Aid flow (current US$) of Ethiopia and Aid flow (current US$) of Guatemala?
Offer a terse response. -3.83e+06. In the year 1998, what is the difference between the Aid flow (current US$) of Ethiopia and Aid flow (current US$) of South Africa?
Your response must be concise. -2.89e+07. In the year 1998, what is the difference between the Aid flow (current US$) in Guatemala and Aid flow (current US$) in South Africa?
Make the answer very short. -2.50e+07. In the year 1999, what is the difference between the Aid flow (current US$) in East Asia (developing only) and Aid flow (current US$) in Ethiopia?
Make the answer very short. 9.10e+07. In the year 1999, what is the difference between the Aid flow (current US$) in East Asia (developing only) and Aid flow (current US$) in Guatemala?
Ensure brevity in your answer.  8.91e+07. In the year 1999, what is the difference between the Aid flow (current US$) in East Asia (developing only) and Aid flow (current US$) in South Africa?
Offer a terse response. 7.79e+07. In the year 1999, what is the difference between the Aid flow (current US$) of Ethiopia and Aid flow (current US$) of Guatemala?
Your response must be concise. -1.90e+06. In the year 1999, what is the difference between the Aid flow (current US$) in Ethiopia and Aid flow (current US$) in South Africa?
Offer a very short reply. -1.31e+07. In the year 1999, what is the difference between the Aid flow (current US$) of Guatemala and Aid flow (current US$) of South Africa?
Provide a succinct answer. -1.12e+07. In the year 2000, what is the difference between the Aid flow (current US$) in East Asia (developing only) and Aid flow (current US$) in Ethiopia?
Provide a short and direct response. 6.39e+07. In the year 2000, what is the difference between the Aid flow (current US$) in East Asia (developing only) and Aid flow (current US$) in Guatemala?
Your answer should be compact. 6.10e+07. In the year 2000, what is the difference between the Aid flow (current US$) in East Asia (developing only) and Aid flow (current US$) in South Africa?
Your answer should be compact. 4.95e+07. In the year 2000, what is the difference between the Aid flow (current US$) of Ethiopia and Aid flow (current US$) of Guatemala?
Ensure brevity in your answer.  -2.87e+06. In the year 2000, what is the difference between the Aid flow (current US$) in Ethiopia and Aid flow (current US$) in South Africa?
Ensure brevity in your answer.  -1.44e+07. In the year 2000, what is the difference between the Aid flow (current US$) of Guatemala and Aid flow (current US$) of South Africa?
Give a very brief answer. -1.15e+07. In the year 2001, what is the difference between the Aid flow (current US$) of East Asia (developing only) and Aid flow (current US$) of Ethiopia?
Offer a terse response. 1.14e+08. In the year 2001, what is the difference between the Aid flow (current US$) in East Asia (developing only) and Aid flow (current US$) in Guatemala?
Your answer should be compact. 1.15e+08. In the year 2001, what is the difference between the Aid flow (current US$) in East Asia (developing only) and Aid flow (current US$) in South Africa?
Your answer should be very brief. 1.01e+08. In the year 2001, what is the difference between the Aid flow (current US$) of Ethiopia and Aid flow (current US$) of Guatemala?
Provide a short and direct response. 7.50e+05. In the year 2001, what is the difference between the Aid flow (current US$) in Ethiopia and Aid flow (current US$) in South Africa?
Your answer should be compact. -1.25e+07. In the year 2001, what is the difference between the Aid flow (current US$) in Guatemala and Aid flow (current US$) in South Africa?
Your answer should be very brief. -1.33e+07. In the year 2002, what is the difference between the Aid flow (current US$) of East Asia (developing only) and Aid flow (current US$) of Ethiopia?
Your response must be concise. 1.04e+08. In the year 2002, what is the difference between the Aid flow (current US$) of East Asia (developing only) and Aid flow (current US$) of Guatemala?
Keep it short and to the point. 1.05e+08. In the year 2002, what is the difference between the Aid flow (current US$) of East Asia (developing only) and Aid flow (current US$) of South Africa?
Your response must be concise. 8.82e+07. In the year 2002, what is the difference between the Aid flow (current US$) in Ethiopia and Aid flow (current US$) in Guatemala?
Keep it short and to the point. 7.70e+05. In the year 2002, what is the difference between the Aid flow (current US$) in Ethiopia and Aid flow (current US$) in South Africa?
Ensure brevity in your answer.  -1.61e+07. In the year 2002, what is the difference between the Aid flow (current US$) in Guatemala and Aid flow (current US$) in South Africa?
Your answer should be compact. -1.68e+07. In the year 2003, what is the difference between the Aid flow (current US$) of East Asia (developing only) and Aid flow (current US$) of Ethiopia?
Your answer should be very brief. 8.31e+07. In the year 2003, what is the difference between the Aid flow (current US$) of East Asia (developing only) and Aid flow (current US$) of Guatemala?
Offer a terse response. 8.16e+07. In the year 2003, what is the difference between the Aid flow (current US$) in East Asia (developing only) and Aid flow (current US$) in South Africa?
Make the answer very short. 6.55e+07. In the year 2003, what is the difference between the Aid flow (current US$) in Ethiopia and Aid flow (current US$) in Guatemala?
Your answer should be compact. -1.47e+06. In the year 2003, what is the difference between the Aid flow (current US$) in Ethiopia and Aid flow (current US$) in South Africa?
Ensure brevity in your answer.  -1.76e+07. In the year 2003, what is the difference between the Aid flow (current US$) of Guatemala and Aid flow (current US$) of South Africa?
Make the answer very short. -1.61e+07. What is the ratio of the Aid flow (current US$) in East Asia (developing only) in 1996 to that in 1997?
Provide a succinct answer. 0.91. What is the ratio of the Aid flow (current US$) of Ethiopia in 1996 to that in 1997?
Provide a succinct answer. 1.29. What is the ratio of the Aid flow (current US$) in Guatemala in 1996 to that in 1997?
Make the answer very short. 0.18. What is the ratio of the Aid flow (current US$) of South Africa in 1996 to that in 1997?
Give a very brief answer. 0.84. What is the ratio of the Aid flow (current US$) of East Asia (developing only) in 1996 to that in 1998?
Ensure brevity in your answer.  1.59. What is the ratio of the Aid flow (current US$) of Ethiopia in 1996 to that in 1998?
Your response must be concise. 1.46. What is the ratio of the Aid flow (current US$) of Guatemala in 1996 to that in 1998?
Keep it short and to the point. 0.28. What is the ratio of the Aid flow (current US$) in South Africa in 1996 to that in 1998?
Give a very brief answer. 0.94. What is the ratio of the Aid flow (current US$) in East Asia (developing only) in 1996 to that in 1999?
Offer a very short reply. 1.01. What is the ratio of the Aid flow (current US$) in Ethiopia in 1996 to that in 1999?
Your answer should be very brief. 1.11. What is the ratio of the Aid flow (current US$) of Guatemala in 1996 to that in 1999?
Your answer should be very brief. 0.33. What is the ratio of the Aid flow (current US$) in South Africa in 1996 to that in 1999?
Your response must be concise. 1.74. What is the ratio of the Aid flow (current US$) in East Asia (developing only) in 1996 to that in 2000?
Your answer should be compact. 1.45. What is the ratio of the Aid flow (current US$) in Ethiopia in 1996 to that in 2000?
Provide a succinct answer. 1.77. What is the ratio of the Aid flow (current US$) in Guatemala in 1996 to that in 2000?
Make the answer very short. 0.36. What is the ratio of the Aid flow (current US$) of South Africa in 1996 to that in 2000?
Your response must be concise. 1.77. What is the ratio of the Aid flow (current US$) in East Asia (developing only) in 1996 to that in 2001?
Offer a very short reply. 0.83. What is the ratio of the Aid flow (current US$) in Ethiopia in 1996 to that in 2001?
Provide a succinct answer. 1.65. What is the ratio of the Aid flow (current US$) of South Africa in 1996 to that in 2001?
Make the answer very short. 1.96. What is the ratio of the Aid flow (current US$) of East Asia (developing only) in 1996 to that in 2002?
Offer a terse response. 0.9. What is the ratio of the Aid flow (current US$) of Ethiopia in 1996 to that in 2002?
Offer a terse response. 1.69. What is the ratio of the Aid flow (current US$) in Guatemala in 1996 to that in 2002?
Keep it short and to the point. 1.02. What is the ratio of the Aid flow (current US$) in South Africa in 1996 to that in 2002?
Your answer should be very brief. 1.6. What is the ratio of the Aid flow (current US$) in East Asia (developing only) in 1996 to that in 2003?
Give a very brief answer. 1.12. What is the ratio of the Aid flow (current US$) of Ethiopia in 1996 to that in 2003?
Your response must be concise. 1.53. What is the ratio of the Aid flow (current US$) of Guatemala in 1996 to that in 2003?
Your response must be concise. 0.44. What is the ratio of the Aid flow (current US$) of South Africa in 1996 to that in 2003?
Offer a terse response. 1.46. What is the ratio of the Aid flow (current US$) in East Asia (developing only) in 1997 to that in 1998?
Your response must be concise. 1.74. What is the ratio of the Aid flow (current US$) of Ethiopia in 1997 to that in 1998?
Offer a terse response. 1.13. What is the ratio of the Aid flow (current US$) in Guatemala in 1997 to that in 1998?
Ensure brevity in your answer.  1.53. What is the ratio of the Aid flow (current US$) of South Africa in 1997 to that in 1998?
Your answer should be very brief. 1.12. What is the ratio of the Aid flow (current US$) of East Asia (developing only) in 1997 to that in 1999?
Provide a succinct answer. 1.11. What is the ratio of the Aid flow (current US$) of Ethiopia in 1997 to that in 1999?
Your response must be concise. 0.86. What is the ratio of the Aid flow (current US$) in Guatemala in 1997 to that in 1999?
Keep it short and to the point. 1.77. What is the ratio of the Aid flow (current US$) in South Africa in 1997 to that in 1999?
Your response must be concise. 2.07. What is the ratio of the Aid flow (current US$) of East Asia (developing only) in 1997 to that in 2000?
Your response must be concise. 1.58. What is the ratio of the Aid flow (current US$) in Ethiopia in 1997 to that in 2000?
Provide a short and direct response. 1.38. What is the ratio of the Aid flow (current US$) in Guatemala in 1997 to that in 2000?
Offer a terse response. 1.96. What is the ratio of the Aid flow (current US$) of South Africa in 1997 to that in 2000?
Offer a terse response. 2.1. What is the ratio of the Aid flow (current US$) in East Asia (developing only) in 1997 to that in 2001?
Give a very brief answer. 0.9. What is the ratio of the Aid flow (current US$) of Ethiopia in 1997 to that in 2001?
Offer a very short reply. 1.28. What is the ratio of the Aid flow (current US$) in Guatemala in 1997 to that in 2001?
Make the answer very short. 5.32. What is the ratio of the Aid flow (current US$) of South Africa in 1997 to that in 2001?
Make the answer very short. 2.34. What is the ratio of the Aid flow (current US$) in East Asia (developing only) in 1997 to that in 2002?
Give a very brief answer. 0.98. What is the ratio of the Aid flow (current US$) in Ethiopia in 1997 to that in 2002?
Provide a succinct answer. 1.31. What is the ratio of the Aid flow (current US$) of Guatemala in 1997 to that in 2002?
Give a very brief answer. 5.57. What is the ratio of the Aid flow (current US$) of South Africa in 1997 to that in 2002?
Give a very brief answer. 1.9. What is the ratio of the Aid flow (current US$) in East Asia (developing only) in 1997 to that in 2003?
Make the answer very short. 1.22. What is the ratio of the Aid flow (current US$) in Ethiopia in 1997 to that in 2003?
Offer a terse response. 1.19. What is the ratio of the Aid flow (current US$) in Guatemala in 1997 to that in 2003?
Provide a succinct answer. 2.39. What is the ratio of the Aid flow (current US$) of South Africa in 1997 to that in 2003?
Ensure brevity in your answer.  1.73. What is the ratio of the Aid flow (current US$) of East Asia (developing only) in 1998 to that in 1999?
Ensure brevity in your answer.  0.63. What is the ratio of the Aid flow (current US$) in Ethiopia in 1998 to that in 1999?
Give a very brief answer. 0.76. What is the ratio of the Aid flow (current US$) of Guatemala in 1998 to that in 1999?
Your answer should be very brief. 1.16. What is the ratio of the Aid flow (current US$) of South Africa in 1998 to that in 1999?
Provide a succinct answer. 1.86. What is the ratio of the Aid flow (current US$) of East Asia (developing only) in 1998 to that in 2000?
Your answer should be very brief. 0.91. What is the ratio of the Aid flow (current US$) in Ethiopia in 1998 to that in 2000?
Offer a very short reply. 1.21. What is the ratio of the Aid flow (current US$) of Guatemala in 1998 to that in 2000?
Your answer should be compact. 1.28. What is the ratio of the Aid flow (current US$) of South Africa in 1998 to that in 2000?
Ensure brevity in your answer.  1.89. What is the ratio of the Aid flow (current US$) in East Asia (developing only) in 1998 to that in 2001?
Provide a short and direct response. 0.52. What is the ratio of the Aid flow (current US$) of Ethiopia in 1998 to that in 2001?
Make the answer very short. 1.13. What is the ratio of the Aid flow (current US$) in Guatemala in 1998 to that in 2001?
Offer a terse response. 3.47. What is the ratio of the Aid flow (current US$) in South Africa in 1998 to that in 2001?
Keep it short and to the point. 2.1. What is the ratio of the Aid flow (current US$) of East Asia (developing only) in 1998 to that in 2002?
Offer a terse response. 0.56. What is the ratio of the Aid flow (current US$) in Ethiopia in 1998 to that in 2002?
Ensure brevity in your answer.  1.16. What is the ratio of the Aid flow (current US$) of Guatemala in 1998 to that in 2002?
Your answer should be very brief. 3.63. What is the ratio of the Aid flow (current US$) of South Africa in 1998 to that in 2002?
Provide a short and direct response. 1.71. What is the ratio of the Aid flow (current US$) of East Asia (developing only) in 1998 to that in 2003?
Keep it short and to the point. 0.7. What is the ratio of the Aid flow (current US$) of Ethiopia in 1998 to that in 2003?
Your response must be concise. 1.05. What is the ratio of the Aid flow (current US$) of Guatemala in 1998 to that in 2003?
Your answer should be compact. 1.56. What is the ratio of the Aid flow (current US$) of South Africa in 1998 to that in 2003?
Your response must be concise. 1.56. What is the ratio of the Aid flow (current US$) of East Asia (developing only) in 1999 to that in 2000?
Ensure brevity in your answer.  1.43. What is the ratio of the Aid flow (current US$) of Ethiopia in 1999 to that in 2000?
Make the answer very short. 1.6. What is the ratio of the Aid flow (current US$) in Guatemala in 1999 to that in 2000?
Your answer should be very brief. 1.1. What is the ratio of the Aid flow (current US$) of South Africa in 1999 to that in 2000?
Keep it short and to the point. 1.01. What is the ratio of the Aid flow (current US$) of East Asia (developing only) in 1999 to that in 2001?
Provide a succinct answer. 0.82. What is the ratio of the Aid flow (current US$) in Ethiopia in 1999 to that in 2001?
Make the answer very short. 1.49. What is the ratio of the Aid flow (current US$) of Guatemala in 1999 to that in 2001?
Make the answer very short. 3. What is the ratio of the Aid flow (current US$) of South Africa in 1999 to that in 2001?
Offer a terse response. 1.13. What is the ratio of the Aid flow (current US$) of Ethiopia in 1999 to that in 2002?
Your response must be concise. 1.53. What is the ratio of the Aid flow (current US$) of Guatemala in 1999 to that in 2002?
Give a very brief answer. 3.14. What is the ratio of the Aid flow (current US$) of South Africa in 1999 to that in 2002?
Ensure brevity in your answer.  0.92. What is the ratio of the Aid flow (current US$) of East Asia (developing only) in 1999 to that in 2003?
Provide a short and direct response. 1.1. What is the ratio of the Aid flow (current US$) in Ethiopia in 1999 to that in 2003?
Your answer should be compact. 1.38. What is the ratio of the Aid flow (current US$) in Guatemala in 1999 to that in 2003?
Offer a very short reply. 1.35. What is the ratio of the Aid flow (current US$) in South Africa in 1999 to that in 2003?
Ensure brevity in your answer.  0.84. What is the ratio of the Aid flow (current US$) of East Asia (developing only) in 2000 to that in 2001?
Your answer should be very brief. 0.57. What is the ratio of the Aid flow (current US$) of Ethiopia in 2000 to that in 2001?
Your answer should be compact. 0.93. What is the ratio of the Aid flow (current US$) of Guatemala in 2000 to that in 2001?
Your answer should be very brief. 2.71. What is the ratio of the Aid flow (current US$) in South Africa in 2000 to that in 2001?
Provide a succinct answer. 1.11. What is the ratio of the Aid flow (current US$) in East Asia (developing only) in 2000 to that in 2002?
Offer a terse response. 0.62. What is the ratio of the Aid flow (current US$) of Ethiopia in 2000 to that in 2002?
Ensure brevity in your answer.  0.96. What is the ratio of the Aid flow (current US$) of Guatemala in 2000 to that in 2002?
Your answer should be very brief. 2.84. What is the ratio of the Aid flow (current US$) of South Africa in 2000 to that in 2002?
Offer a very short reply. 0.91. What is the ratio of the Aid flow (current US$) in East Asia (developing only) in 2000 to that in 2003?
Make the answer very short. 0.77. What is the ratio of the Aid flow (current US$) of Ethiopia in 2000 to that in 2003?
Provide a short and direct response. 0.86. What is the ratio of the Aid flow (current US$) in Guatemala in 2000 to that in 2003?
Provide a succinct answer. 1.22. What is the ratio of the Aid flow (current US$) of South Africa in 2000 to that in 2003?
Make the answer very short. 0.82. What is the ratio of the Aid flow (current US$) in East Asia (developing only) in 2001 to that in 2002?
Provide a succinct answer. 1.09. What is the ratio of the Aid flow (current US$) of Ethiopia in 2001 to that in 2002?
Make the answer very short. 1.03. What is the ratio of the Aid flow (current US$) in Guatemala in 2001 to that in 2002?
Your answer should be very brief. 1.05. What is the ratio of the Aid flow (current US$) in South Africa in 2001 to that in 2002?
Provide a short and direct response. 0.81. What is the ratio of the Aid flow (current US$) of East Asia (developing only) in 2001 to that in 2003?
Give a very brief answer. 1.35. What is the ratio of the Aid flow (current US$) in Ethiopia in 2001 to that in 2003?
Ensure brevity in your answer.  0.93. What is the ratio of the Aid flow (current US$) of Guatemala in 2001 to that in 2003?
Keep it short and to the point. 0.45. What is the ratio of the Aid flow (current US$) in South Africa in 2001 to that in 2003?
Your response must be concise. 0.74. What is the ratio of the Aid flow (current US$) of East Asia (developing only) in 2002 to that in 2003?
Give a very brief answer. 1.24. What is the ratio of the Aid flow (current US$) in Ethiopia in 2002 to that in 2003?
Give a very brief answer. 0.9. What is the ratio of the Aid flow (current US$) of Guatemala in 2002 to that in 2003?
Give a very brief answer. 0.43. What is the ratio of the Aid flow (current US$) of South Africa in 2002 to that in 2003?
Keep it short and to the point. 0.91. What is the difference between the highest and the second highest Aid flow (current US$) of East Asia (developing only)?
Make the answer very short. 9.58e+06. What is the difference between the highest and the second highest Aid flow (current US$) of Ethiopia?
Offer a terse response. 4.40e+05. What is the difference between the highest and the second highest Aid flow (current US$) in Guatemala?
Your response must be concise. 3.69e+06. What is the difference between the highest and the second highest Aid flow (current US$) in South Africa?
Give a very brief answer. 3.69e+06. What is the difference between the highest and the lowest Aid flow (current US$) in East Asia (developing only)?
Provide a short and direct response. 5.62e+07. What is the difference between the highest and the lowest Aid flow (current US$) of Ethiopia?
Provide a succinct answer. 1.97e+06. What is the difference between the highest and the lowest Aid flow (current US$) in Guatemala?
Your response must be concise. 8.72e+06. What is the difference between the highest and the lowest Aid flow (current US$) in South Africa?
Your response must be concise. 2.04e+07. 